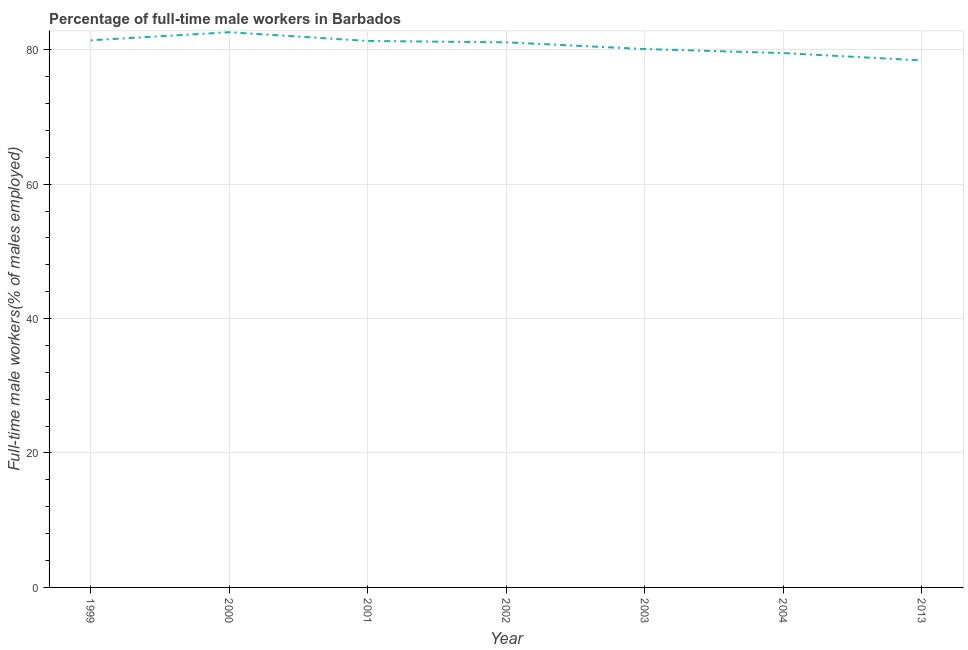What is the percentage of full-time male workers in 2002?
Give a very brief answer. 81.1. Across all years, what is the maximum percentage of full-time male workers?
Your answer should be very brief. 82.6. Across all years, what is the minimum percentage of full-time male workers?
Make the answer very short. 78.4. In which year was the percentage of full-time male workers minimum?
Offer a very short reply. 2013. What is the sum of the percentage of full-time male workers?
Provide a short and direct response. 564.4. What is the average percentage of full-time male workers per year?
Give a very brief answer. 80.63. What is the median percentage of full-time male workers?
Make the answer very short. 81.1. What is the ratio of the percentage of full-time male workers in 2002 to that in 2003?
Your response must be concise. 1.01. What is the difference between the highest and the second highest percentage of full-time male workers?
Your answer should be compact. 1.2. Is the sum of the percentage of full-time male workers in 1999 and 2003 greater than the maximum percentage of full-time male workers across all years?
Your response must be concise. Yes. What is the difference between the highest and the lowest percentage of full-time male workers?
Your answer should be very brief. 4.2. In how many years, is the percentage of full-time male workers greater than the average percentage of full-time male workers taken over all years?
Your answer should be very brief. 4. Does the percentage of full-time male workers monotonically increase over the years?
Offer a terse response. No. How many lines are there?
Give a very brief answer. 1. What is the difference between two consecutive major ticks on the Y-axis?
Provide a succinct answer. 20. What is the title of the graph?
Your response must be concise. Percentage of full-time male workers in Barbados. What is the label or title of the X-axis?
Make the answer very short. Year. What is the label or title of the Y-axis?
Provide a succinct answer. Full-time male workers(% of males employed). What is the Full-time male workers(% of males employed) of 1999?
Provide a short and direct response. 81.4. What is the Full-time male workers(% of males employed) in 2000?
Your answer should be compact. 82.6. What is the Full-time male workers(% of males employed) of 2001?
Keep it short and to the point. 81.3. What is the Full-time male workers(% of males employed) in 2002?
Your response must be concise. 81.1. What is the Full-time male workers(% of males employed) of 2003?
Your response must be concise. 80.1. What is the Full-time male workers(% of males employed) in 2004?
Provide a succinct answer. 79.5. What is the Full-time male workers(% of males employed) in 2013?
Offer a very short reply. 78.4. What is the difference between the Full-time male workers(% of males employed) in 1999 and 2000?
Ensure brevity in your answer.  -1.2. What is the difference between the Full-time male workers(% of males employed) in 1999 and 2001?
Make the answer very short. 0.1. What is the difference between the Full-time male workers(% of males employed) in 1999 and 2002?
Your answer should be compact. 0.3. What is the difference between the Full-time male workers(% of males employed) in 1999 and 2003?
Offer a terse response. 1.3. What is the difference between the Full-time male workers(% of males employed) in 1999 and 2004?
Make the answer very short. 1.9. What is the difference between the Full-time male workers(% of males employed) in 2000 and 2001?
Make the answer very short. 1.3. What is the difference between the Full-time male workers(% of males employed) in 2000 and 2013?
Give a very brief answer. 4.2. What is the difference between the Full-time male workers(% of males employed) in 2001 and 2004?
Keep it short and to the point. 1.8. What is the difference between the Full-time male workers(% of males employed) in 2003 and 2013?
Your answer should be very brief. 1.7. What is the difference between the Full-time male workers(% of males employed) in 2004 and 2013?
Make the answer very short. 1.1. What is the ratio of the Full-time male workers(% of males employed) in 1999 to that in 2001?
Provide a succinct answer. 1. What is the ratio of the Full-time male workers(% of males employed) in 1999 to that in 2004?
Your answer should be compact. 1.02. What is the ratio of the Full-time male workers(% of males employed) in 1999 to that in 2013?
Make the answer very short. 1.04. What is the ratio of the Full-time male workers(% of males employed) in 2000 to that in 2001?
Offer a very short reply. 1.02. What is the ratio of the Full-time male workers(% of males employed) in 2000 to that in 2003?
Your answer should be compact. 1.03. What is the ratio of the Full-time male workers(% of males employed) in 2000 to that in 2004?
Your answer should be compact. 1.04. What is the ratio of the Full-time male workers(% of males employed) in 2000 to that in 2013?
Ensure brevity in your answer.  1.05. What is the ratio of the Full-time male workers(% of males employed) in 2001 to that in 2002?
Ensure brevity in your answer.  1. What is the ratio of the Full-time male workers(% of males employed) in 2002 to that in 2003?
Ensure brevity in your answer.  1.01. What is the ratio of the Full-time male workers(% of males employed) in 2002 to that in 2013?
Your answer should be very brief. 1.03. What is the ratio of the Full-time male workers(% of males employed) in 2003 to that in 2013?
Provide a succinct answer. 1.02. 